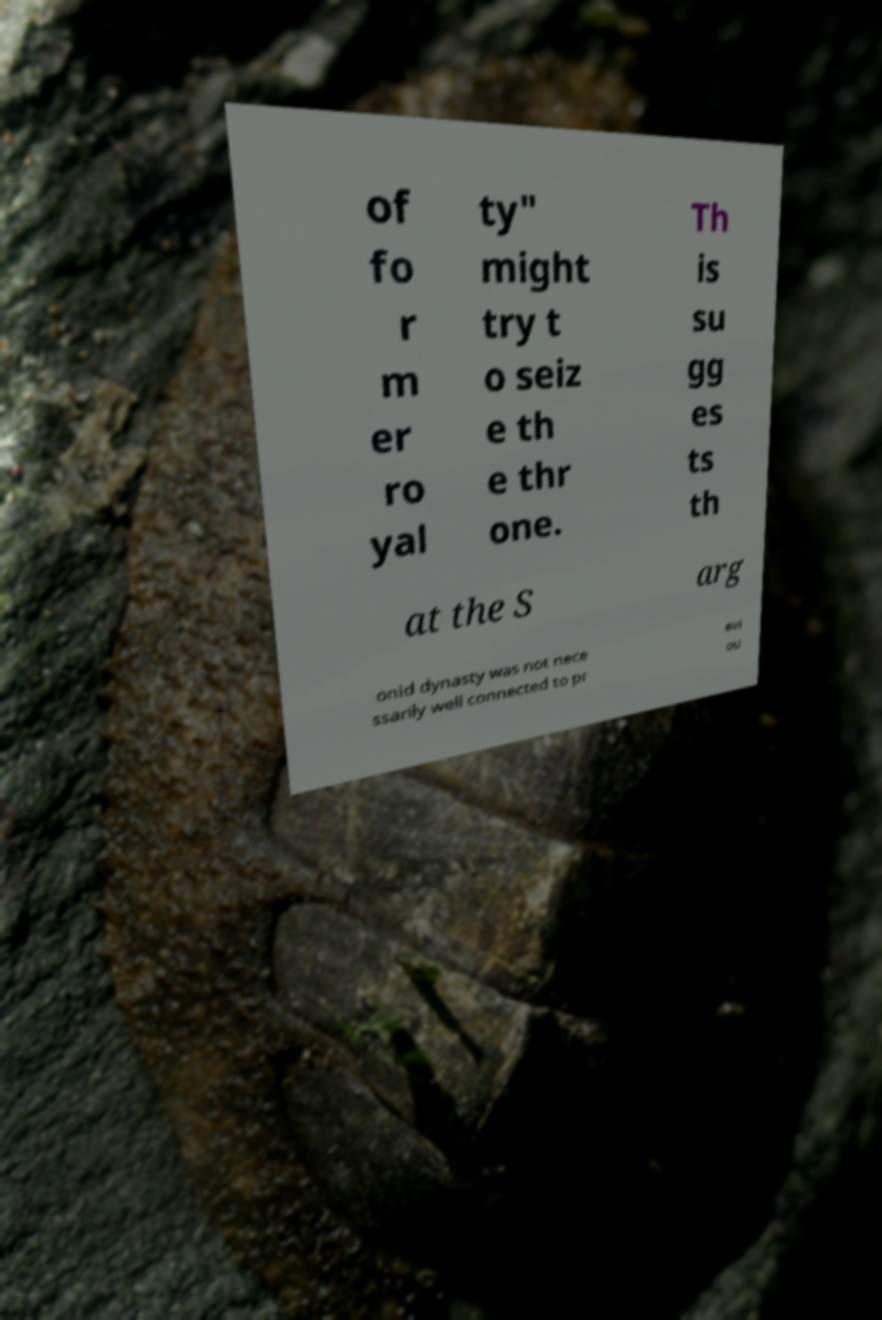There's text embedded in this image that I need extracted. Can you transcribe it verbatim? of fo r m er ro yal ty" might try t o seiz e th e thr one. Th is su gg es ts th at the S arg onid dynasty was not nece ssarily well connected to pr evi ou 